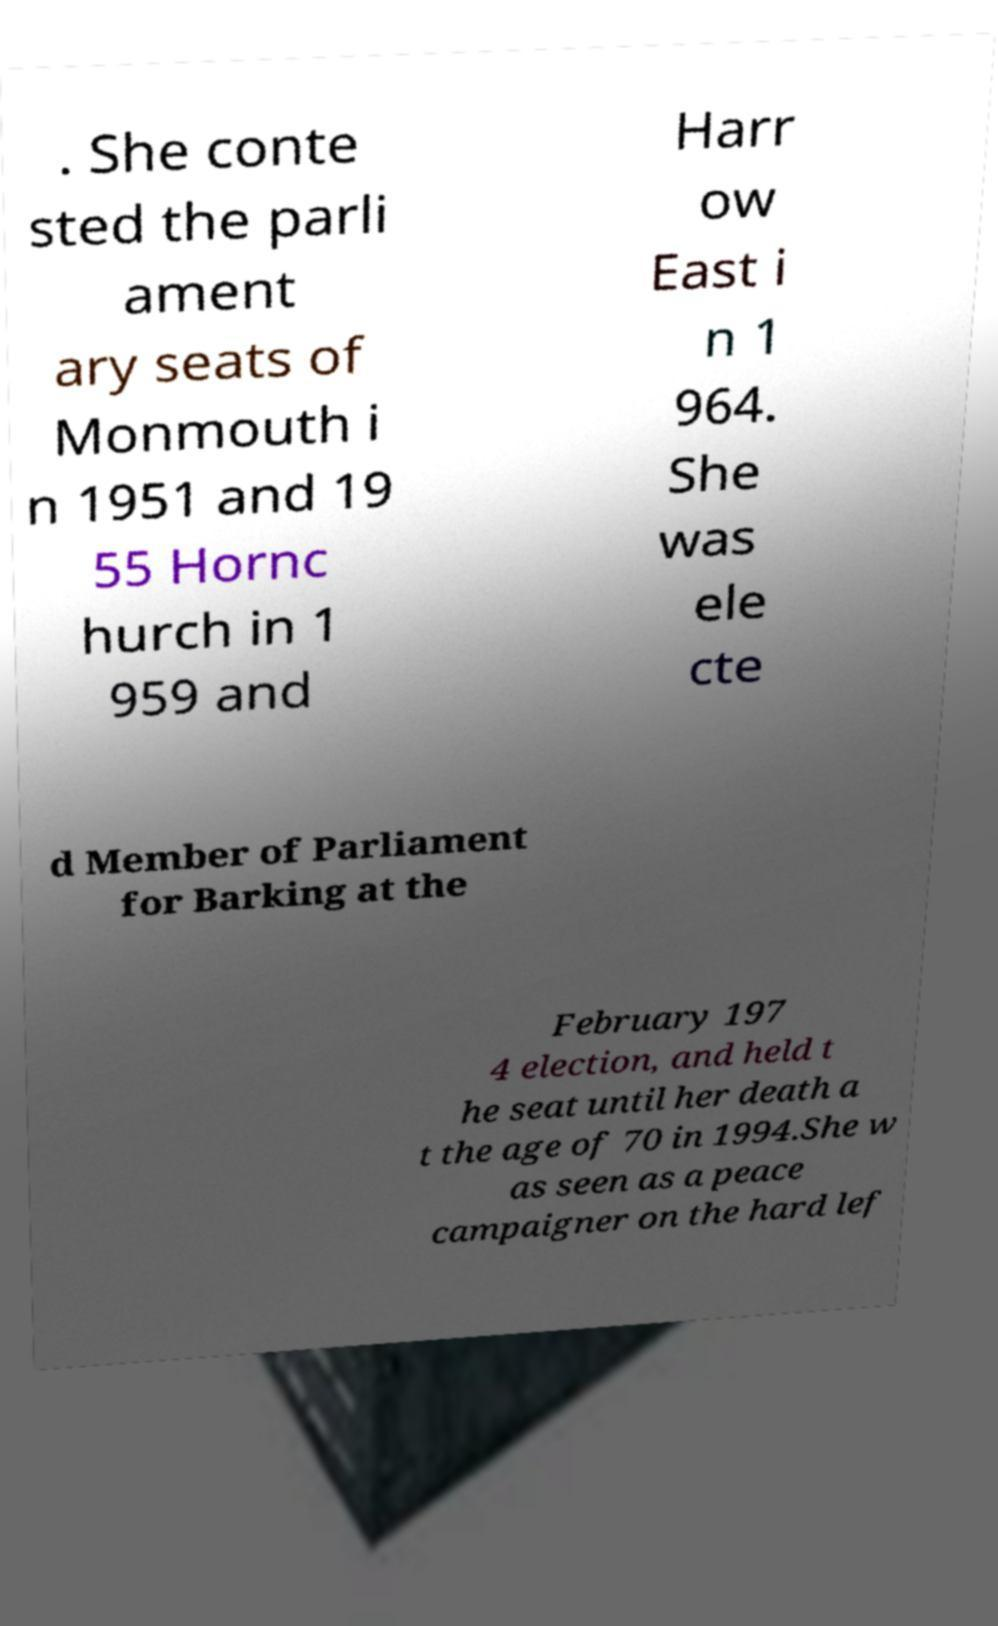I need the written content from this picture converted into text. Can you do that? . She conte sted the parli ament ary seats of Monmouth i n 1951 and 19 55 Hornc hurch in 1 959 and Harr ow East i n 1 964. She was ele cte d Member of Parliament for Barking at the February 197 4 election, and held t he seat until her death a t the age of 70 in 1994.She w as seen as a peace campaigner on the hard lef 